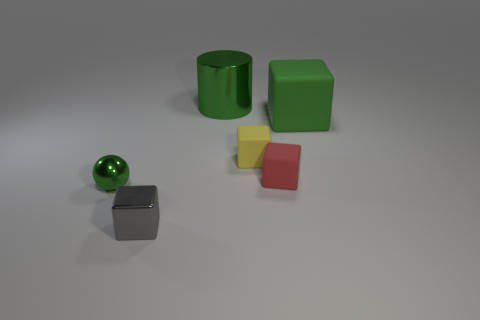Add 1 tiny yellow matte things. How many objects exist? 7 Subtract all balls. How many objects are left? 5 Add 2 small purple matte cylinders. How many small purple matte cylinders exist? 2 Subtract 0 yellow cylinders. How many objects are left? 6 Subtract all tiny matte cubes. Subtract all blocks. How many objects are left? 0 Add 6 small spheres. How many small spheres are left? 7 